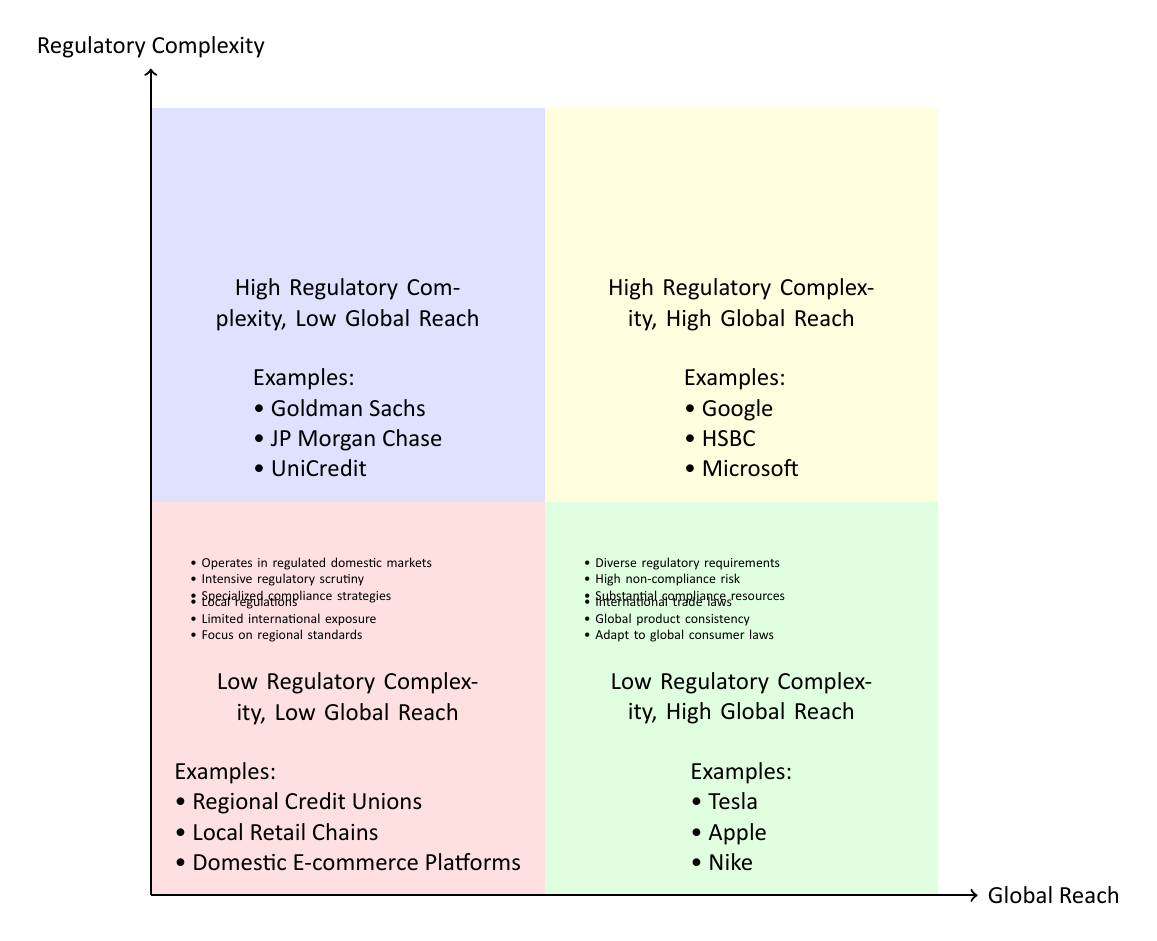What companies are examples of high regulatory complexity and low global reach? The diagram indicates that Goldman Sachs, JP Morgan Chase, and UniCredit are examples of companies situated in the "High Regulatory Complexity, Low Global Reach" quadrant.
Answer: Goldman Sachs, JP Morgan Chase, UniCredit In which quadrant do Tesla and Apple fall? According to the diagram, Tesla and Apple are situated in the "Low Regulatory Complexity, High Global Reach" quadrant, which indicates they have high global reach but manage lower regulatory complexities.
Answer: Low Regulatory Complexity, High Global Reach How many examples of companies are provided in the quadrant of high regulatory complexity and high global reach? The diagram lists three examples of companies—Google, HSBC, and Microsoft—in the "High Regulatory Complexity, High Global Reach" quadrant, indicating a strong presence in various global markets alongside high regulatory demands.
Answer: 3 What characteristic is shared by companies in low regulatory complexity and low global reach? The characteristic shared by companies in the quadrant "Low Regulatory Complexity, Low Global Reach" is that they are primarily governed by local regulations with limited international exposure, leading to fewer compliance obligations.
Answer: Governed by local regulations Which quadrant has a focus on maintaining compliance with regional standards? The "Low Regulatory Complexity, Low Global Reach" quadrant is dedicated to entities that center their operations on maintaining compliance with specific regional or national standards, indicating a limited scope of regulatory obligations.
Answer: Low Regulatory Complexity, Low Global Reach What is a common trait of companies in the high regulatory complexity and high global reach quadrant? Companies in the "High Regulatory Complexity, High Global Reach" quadrant share the trait of dealing with diverse regulatory requirements across numerous countries, which makes compliance a significant challenge for them.
Answer: Diverse regulatory requirements 